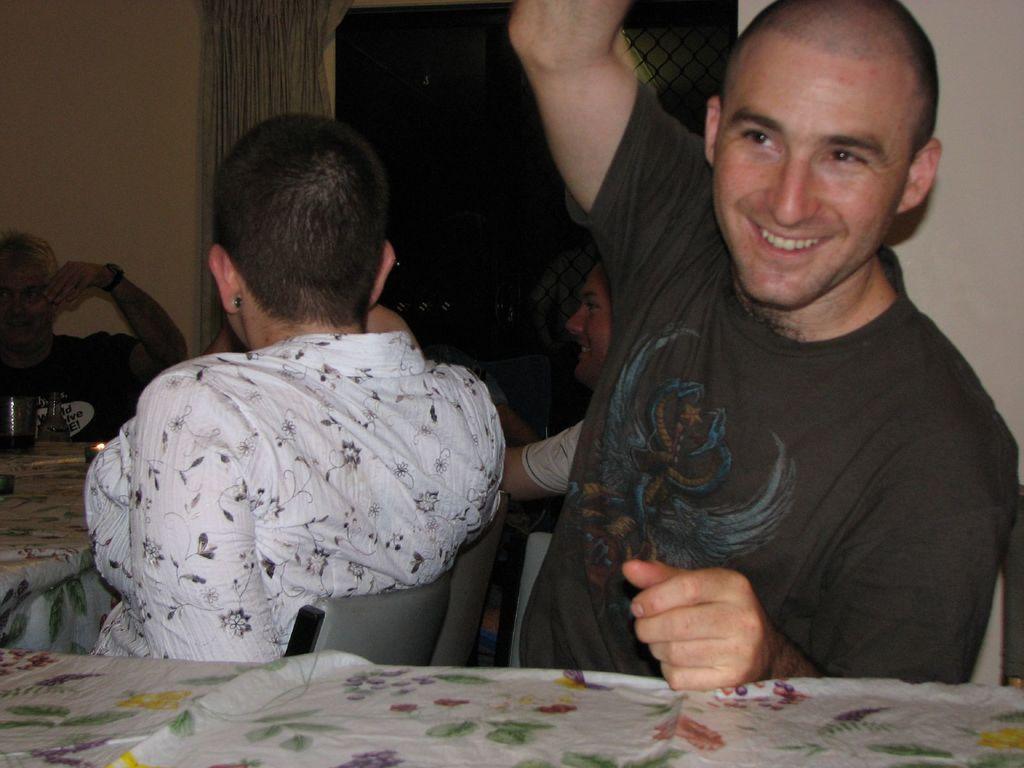Please provide a concise description of this image. In this picture there is a man towards the right. He is wearing a black t shirt and he is sitting beside the table. Towards the left, there is a woman wearing a flower patterned top. Before her, there is a table and people. In the background there is a wall with window and a curtain. 